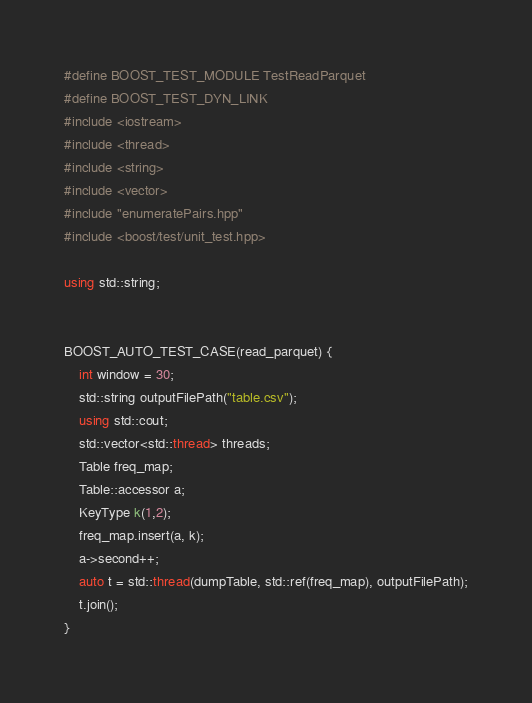Convert code to text. <code><loc_0><loc_0><loc_500><loc_500><_C++_>#define BOOST_TEST_MODULE TestReadParquet
#define BOOST_TEST_DYN_LINK
#include <iostream>
#include <thread>
#include <string>
#include <vector>
#include "enumeratePairs.hpp"
#include <boost/test/unit_test.hpp>

using std::string;


BOOST_AUTO_TEST_CASE(read_parquet) {
    int window = 30;
    std::string outputFilePath("table.csv");
    using std::cout;
    std::vector<std::thread> threads;
    Table freq_map;
    Table::accessor a;
    KeyType k(1,2);
    freq_map.insert(a, k);
    a->second++;
    auto t = std::thread(dumpTable, std::ref(freq_map), outputFilePath);
    t.join();
}
</code> 